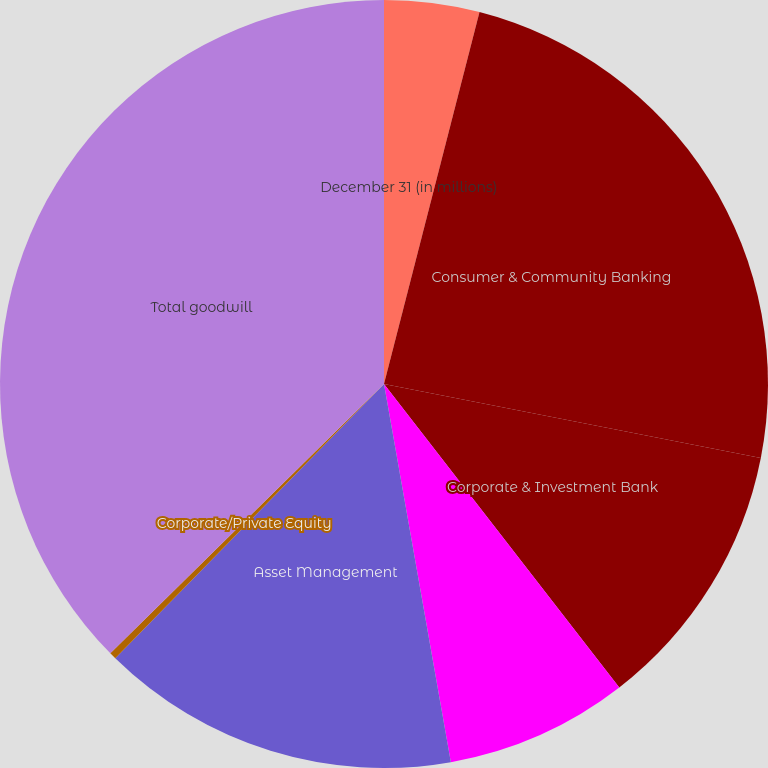<chart> <loc_0><loc_0><loc_500><loc_500><pie_chart><fcel>December 31 (in millions)<fcel>Consumer & Community Banking<fcel>Corporate & Investment Bank<fcel>Commercial Banking<fcel>Asset Management<fcel>Corporate/Private Equity<fcel>Total goodwill<nl><fcel>4.0%<fcel>24.08%<fcel>11.42%<fcel>7.71%<fcel>15.12%<fcel>0.29%<fcel>37.37%<nl></chart> 